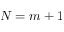Convert formula to latex. <formula><loc_0><loc_0><loc_500><loc_500>N = m + 1</formula> 